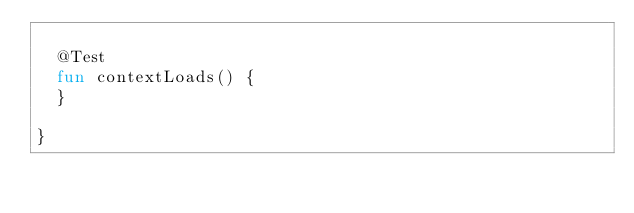<code> <loc_0><loc_0><loc_500><loc_500><_Kotlin_>
	@Test
	fun contextLoads() {
	}

}
</code> 